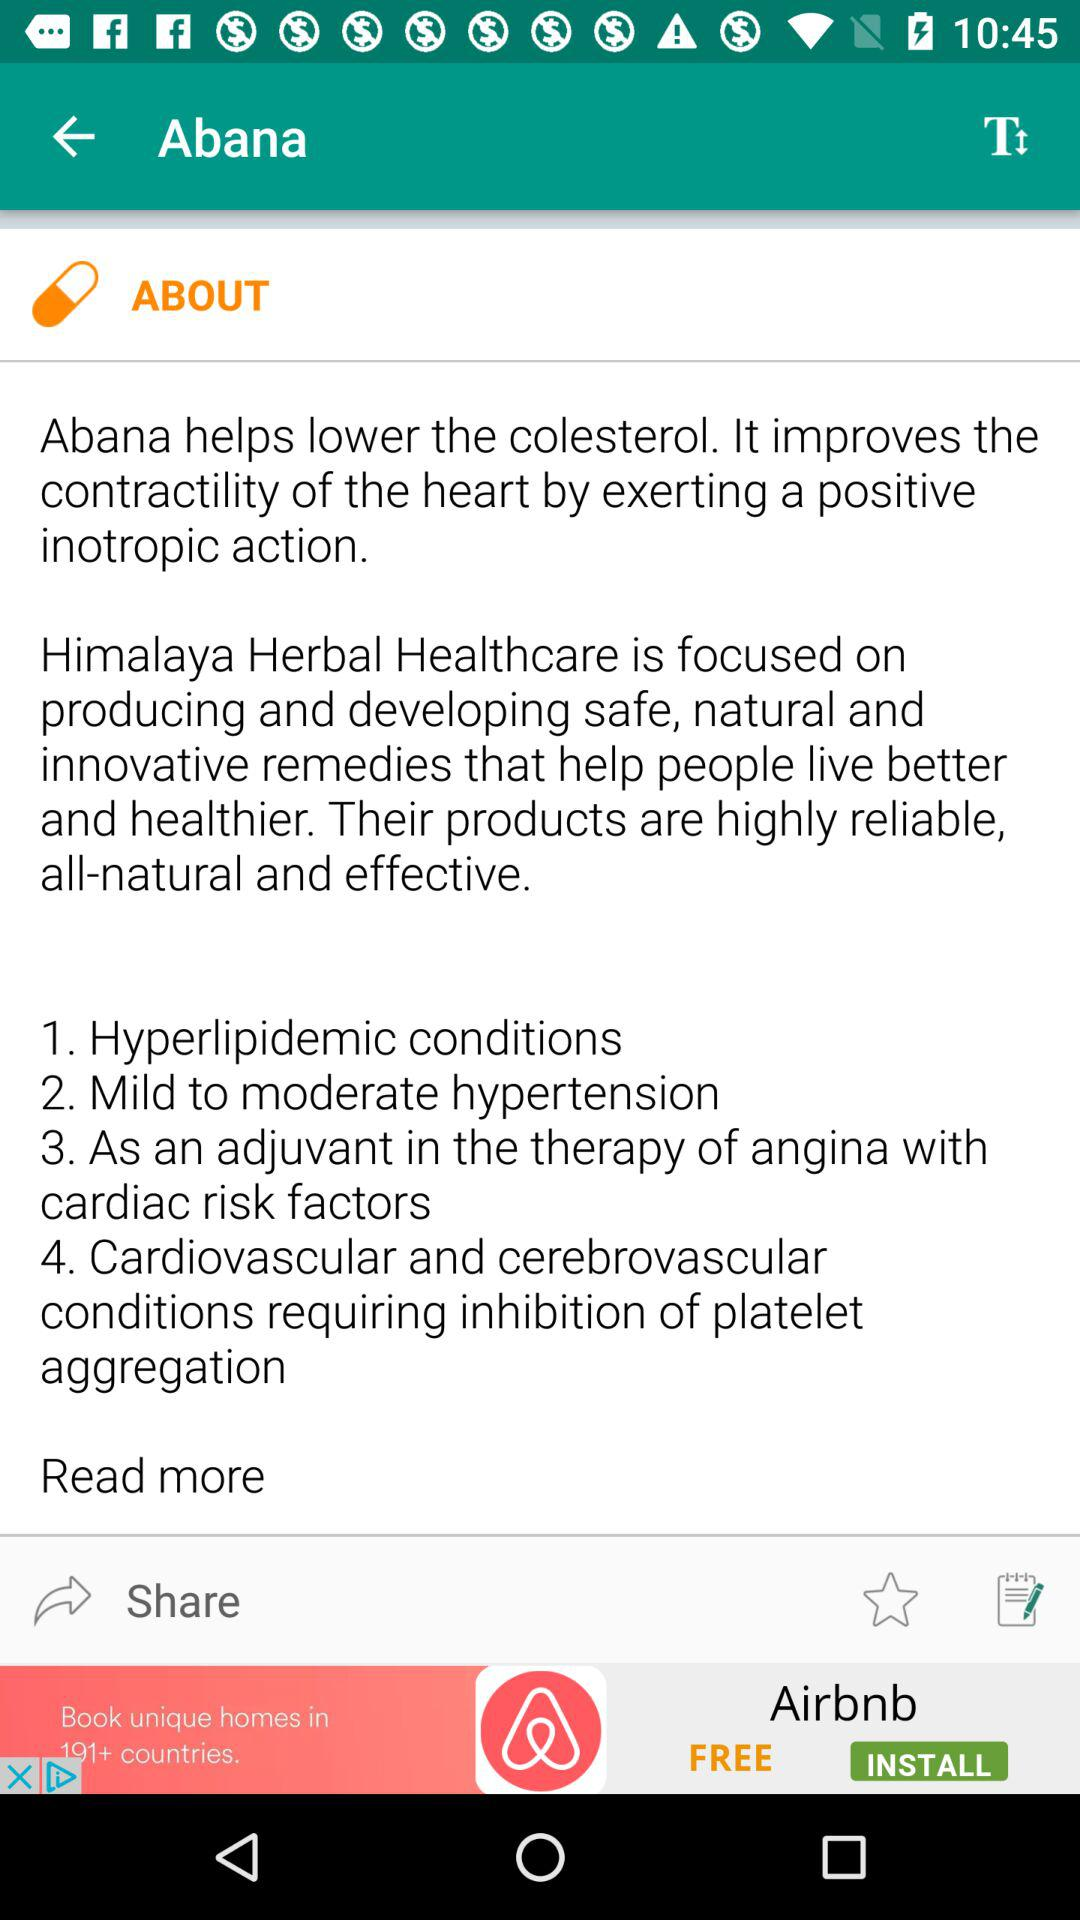What is Himalaya herbal healthcare? Himalaya herbal healthcare is "focused on producing and developing safe, natural and innovative remedies that help people live better and healthier. Their products are highly reliable, all-natural and effective.". 